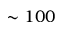Convert formula to latex. <formula><loc_0><loc_0><loc_500><loc_500>\sim 1 0 0</formula> 